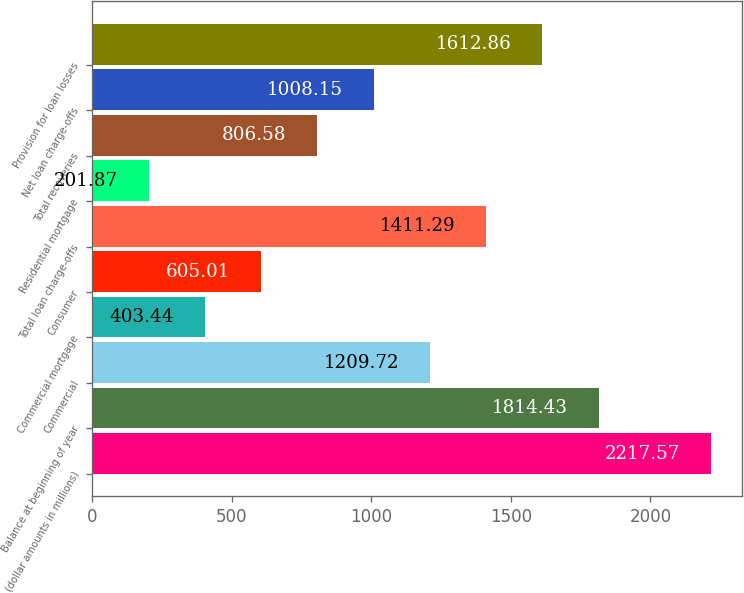<chart> <loc_0><loc_0><loc_500><loc_500><bar_chart><fcel>(dollar amounts in millions)<fcel>Balance at beginning of year<fcel>Commercial<fcel>Commercial mortgage<fcel>Consumer<fcel>Total loan charge-offs<fcel>Residential mortgage<fcel>Total recoveries<fcel>Net loan charge-offs<fcel>Provision for loan losses<nl><fcel>2217.57<fcel>1814.43<fcel>1209.72<fcel>403.44<fcel>605.01<fcel>1411.29<fcel>201.87<fcel>806.58<fcel>1008.15<fcel>1612.86<nl></chart> 